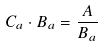<formula> <loc_0><loc_0><loc_500><loc_500>C _ { a } \cdot B _ { a } = \frac { A } { B _ { a } }</formula> 